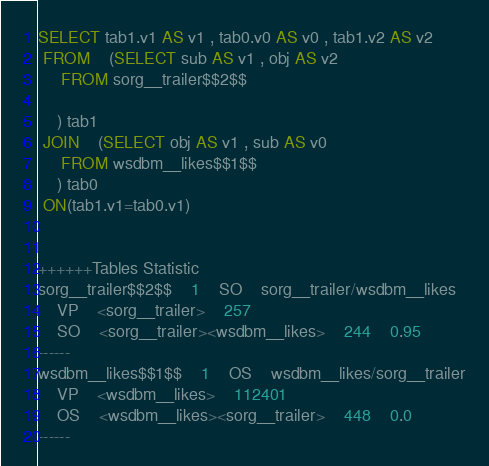<code> <loc_0><loc_0><loc_500><loc_500><_SQL_>SELECT tab1.v1 AS v1 , tab0.v0 AS v0 , tab1.v2 AS v2 
 FROM    (SELECT sub AS v1 , obj AS v2 
	 FROM sorg__trailer$$2$$
	
	) tab1
 JOIN    (SELECT obj AS v1 , sub AS v0 
	 FROM wsdbm__likes$$1$$
	) tab0
 ON(tab1.v1=tab0.v1)


++++++Tables Statistic
sorg__trailer$$2$$	1	SO	sorg__trailer/wsdbm__likes
	VP	<sorg__trailer>	257
	SO	<sorg__trailer><wsdbm__likes>	244	0.95
------
wsdbm__likes$$1$$	1	OS	wsdbm__likes/sorg__trailer
	VP	<wsdbm__likes>	112401
	OS	<wsdbm__likes><sorg__trailer>	448	0.0
------
</code> 